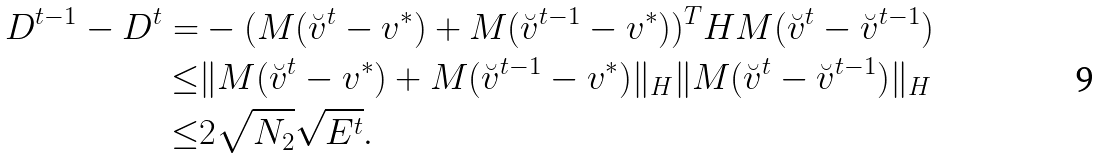<formula> <loc_0><loc_0><loc_500><loc_500>D ^ { t - 1 } - D ^ { t } = & - ( M ( \breve { v } ^ { t } - v ^ { * } ) + M ( \breve { v } ^ { t - 1 } - v ^ { * } ) ) ^ { T } H M ( \breve { v } ^ { t } - \breve { v } ^ { t - 1 } ) \\ \leq & \| M ( \breve { v } ^ { t } - v ^ { * } ) + M ( \breve { v } ^ { t - 1 } - v ^ { * } ) \| _ { H } \| M ( \breve { v } ^ { t } - \breve { v } ^ { t - 1 } ) \| _ { H } \\ \leq & 2 \sqrt { N _ { 2 } } \sqrt { E ^ { t } } .</formula> 